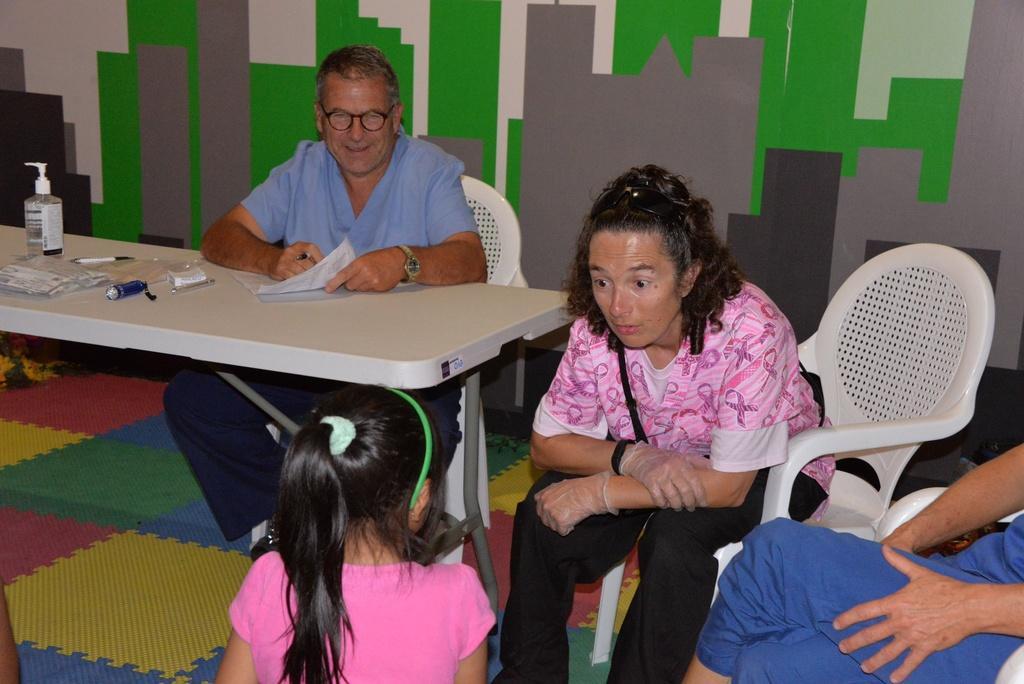In one or two sentences, can you explain what this image depicts? In this image I see 3 persons sitting on the chairs and there is a child over here and I can also see a table and there are few things on it. 